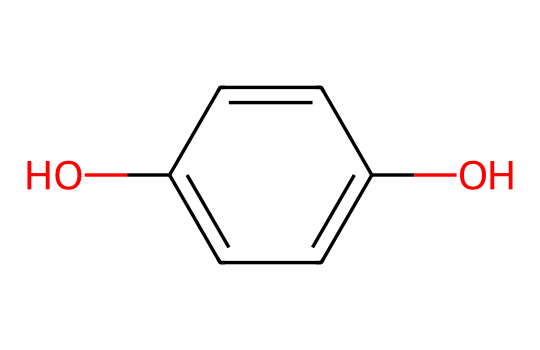What is the name of this chemical? The provided SMILES representation corresponds to a compound known as catechol, which consists of a benzene ring with two hydroxyl (OH) groups attached.
Answer: catechol How many carbon atoms are in this chemical? By analyzing the SMILES structure, the benzene ring contains six carbon atoms. Therefore, the total number of carbon atoms present in catechol is six.
Answer: six What type of functional groups are present in this chemical? The chemical structure features two hydroxyl (OH) groups attached to the benzene ring, which are characteristic of phenolic compounds.
Answer: hydroxyl groups What is the total number of hydrogen atoms in this chemical? Each carbon atom in the benzene ring typically bonds with one hydrogen atom. Given the two hydroxyl groups replace two hydrogen atoms, the total is 4 hydrogen atoms from the ring plus 2 from the hydroxyl groups, resulting in a total of six hydrogen atoms.
Answer: six Is this chemical soluble in water? The presence of two hydroxyl groups in catechol enhances its polarity, making it more soluble in water compared to non-polar hydrocarbons.
Answer: yes What type of isomerism can this chemical exhibit due to its structure? This chemical can exhibit positional isomerism because the two hydroxyl groups can be positioned differently relative to each other on the benzene ring.
Answer: positional isomerism 